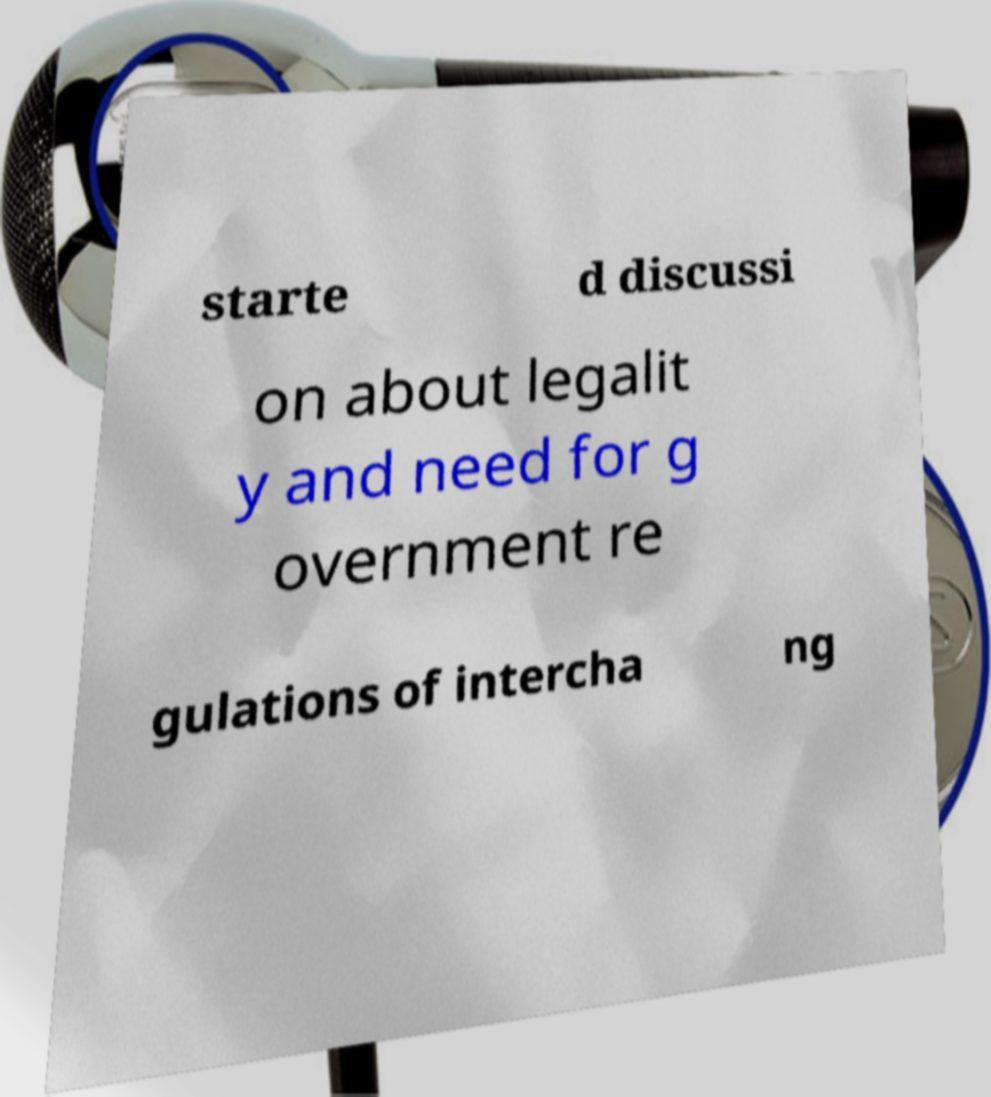Can you read and provide the text displayed in the image?This photo seems to have some interesting text. Can you extract and type it out for me? starte d discussi on about legalit y and need for g overnment re gulations of intercha ng 